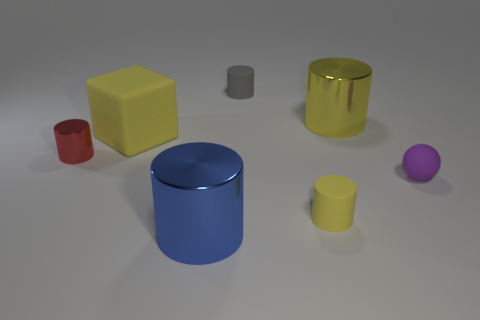Subtract all small matte cylinders. How many cylinders are left? 3 Subtract all red spheres. How many yellow cylinders are left? 2 Subtract all yellow cylinders. How many cylinders are left? 3 Add 1 small gray cylinders. How many objects exist? 8 Subtract 1 cylinders. How many cylinders are left? 4 Subtract all cylinders. How many objects are left? 2 Subtract 1 gray cylinders. How many objects are left? 6 Subtract all cyan cylinders. Subtract all gray spheres. How many cylinders are left? 5 Subtract all tiny red things. Subtract all yellow metallic objects. How many objects are left? 5 Add 1 big yellow matte things. How many big yellow matte things are left? 2 